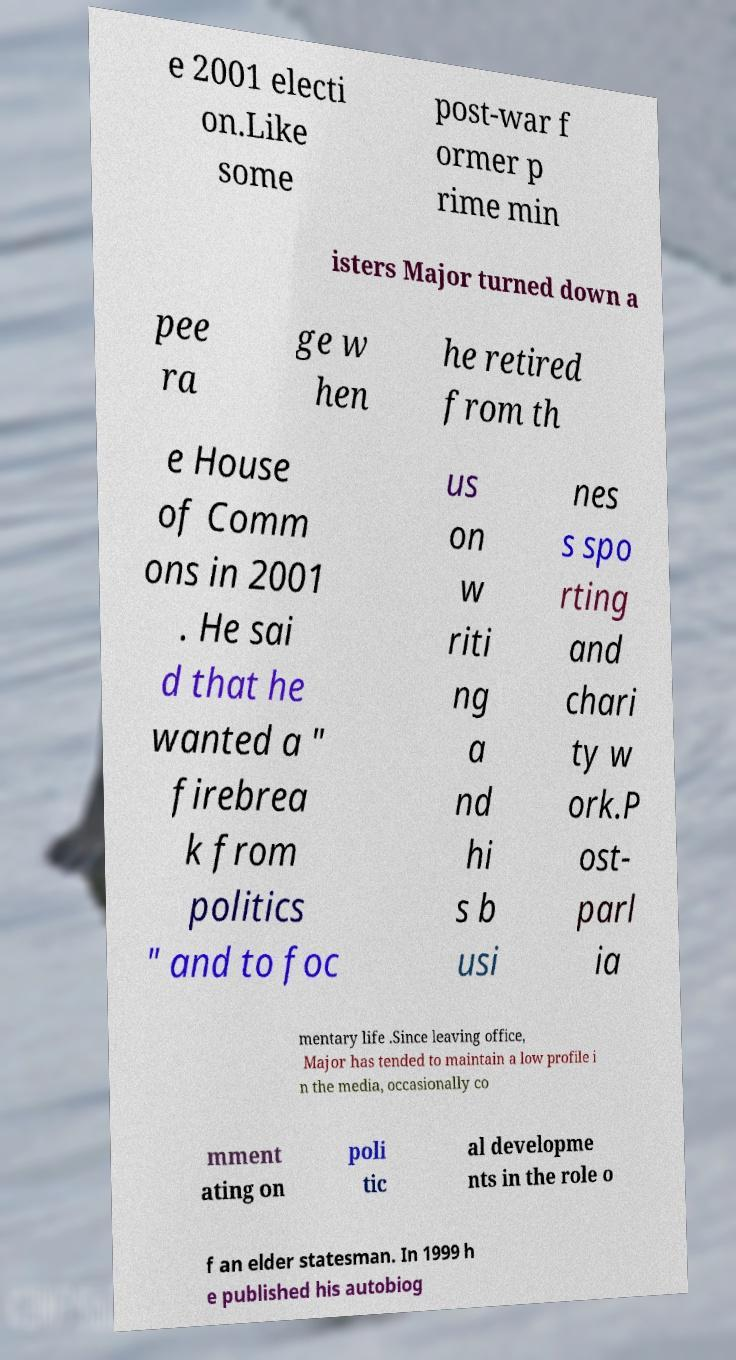Please identify and transcribe the text found in this image. e 2001 electi on.Like some post-war f ormer p rime min isters Major turned down a pee ra ge w hen he retired from th e House of Comm ons in 2001 . He sai d that he wanted a " firebrea k from politics " and to foc us on w riti ng a nd hi s b usi nes s spo rting and chari ty w ork.P ost- parl ia mentary life .Since leaving office, Major has tended to maintain a low profile i n the media, occasionally co mment ating on poli tic al developme nts in the role o f an elder statesman. In 1999 h e published his autobiog 